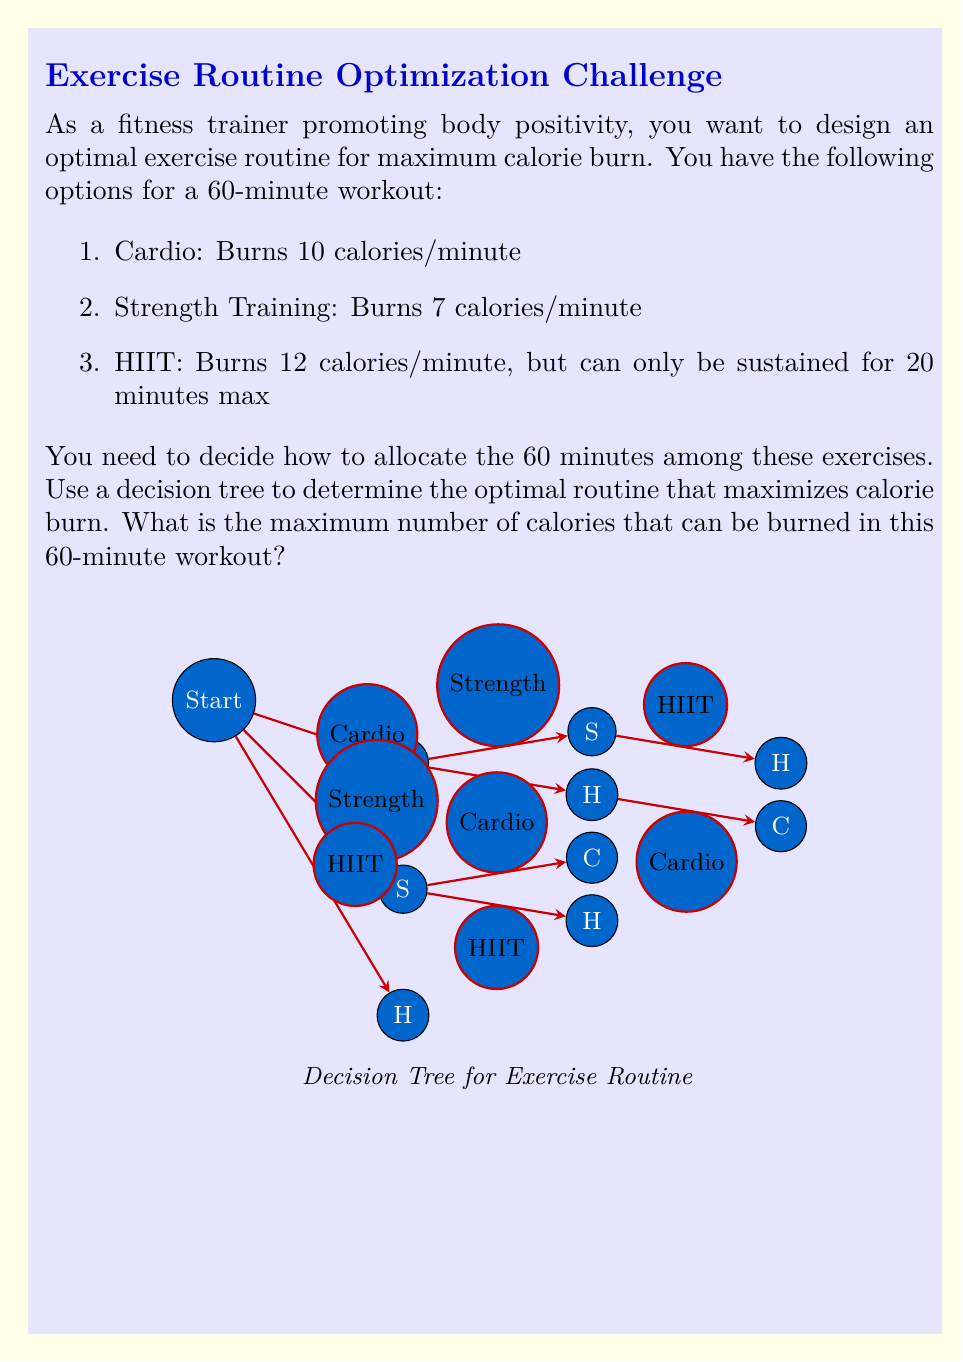Can you answer this question? Let's approach this problem step-by-step using a decision tree:

1) First, we need to consider the constraints:
   - Total workout time is 60 minutes
   - HIIT can only be sustained for 20 minutes max

2) We can start with three main branches: Cardio (C), Strength Training (S), and HIIT (H).

3) Let's calculate the calories burned for each 20-minute segment:
   - Cardio: $20 \times 10 = 200$ calories
   - Strength: $20 \times 7 = 140$ calories
   - HIIT: $20 \times 12 = 240$ calories

4) Now, let's examine each path:

   a) Start with Cardio (C):
      - C -> S -> H: $200 + 140 + 240 = 580$ calories
      - C -> H -> C: $200 + 240 + 200 = 640$ calories

   b) Start with Strength (S):
      - S -> C -> H: $140 + 200 + 240 = 580$ calories
      - S -> H -> C: $140 + 240 + 200 = 580$ calories

   c) Start with HIIT (H):
      - H -> C -> S: $240 + 200 + 140 = 580$ calories
      - H -> S -> C: $240 + 140 + 200 = 580$ calories

5) The optimal path is C -> H -> C, which burns 640 calories.

This routine maximizes calorie burn by utilizing HIIT for its maximum sustainable duration (20 minutes) and filling the remaining time with the next most efficient exercise (Cardio).
Answer: 640 calories 